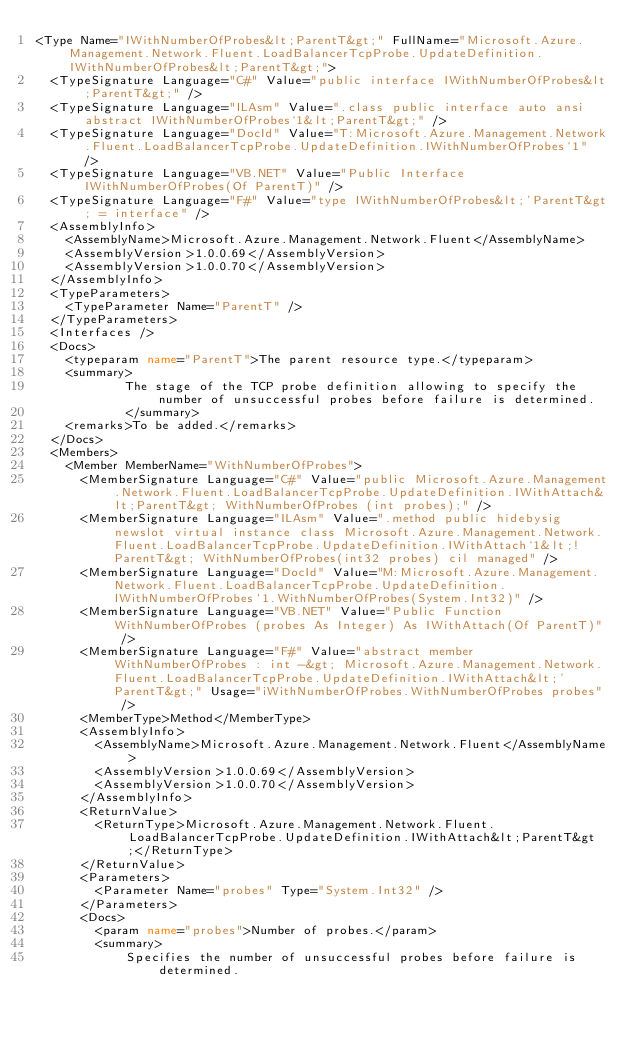Convert code to text. <code><loc_0><loc_0><loc_500><loc_500><_XML_><Type Name="IWithNumberOfProbes&lt;ParentT&gt;" FullName="Microsoft.Azure.Management.Network.Fluent.LoadBalancerTcpProbe.UpdateDefinition.IWithNumberOfProbes&lt;ParentT&gt;">
  <TypeSignature Language="C#" Value="public interface IWithNumberOfProbes&lt;ParentT&gt;" />
  <TypeSignature Language="ILAsm" Value=".class public interface auto ansi abstract IWithNumberOfProbes`1&lt;ParentT&gt;" />
  <TypeSignature Language="DocId" Value="T:Microsoft.Azure.Management.Network.Fluent.LoadBalancerTcpProbe.UpdateDefinition.IWithNumberOfProbes`1" />
  <TypeSignature Language="VB.NET" Value="Public Interface IWithNumberOfProbes(Of ParentT)" />
  <TypeSignature Language="F#" Value="type IWithNumberOfProbes&lt;'ParentT&gt; = interface" />
  <AssemblyInfo>
    <AssemblyName>Microsoft.Azure.Management.Network.Fluent</AssemblyName>
    <AssemblyVersion>1.0.0.69</AssemblyVersion>
    <AssemblyVersion>1.0.0.70</AssemblyVersion>
  </AssemblyInfo>
  <TypeParameters>
    <TypeParameter Name="ParentT" />
  </TypeParameters>
  <Interfaces />
  <Docs>
    <typeparam name="ParentT">The parent resource type.</typeparam>
    <summary>
            The stage of the TCP probe definition allowing to specify the number of unsuccessful probes before failure is determined.
            </summary>
    <remarks>To be added.</remarks>
  </Docs>
  <Members>
    <Member MemberName="WithNumberOfProbes">
      <MemberSignature Language="C#" Value="public Microsoft.Azure.Management.Network.Fluent.LoadBalancerTcpProbe.UpdateDefinition.IWithAttach&lt;ParentT&gt; WithNumberOfProbes (int probes);" />
      <MemberSignature Language="ILAsm" Value=".method public hidebysig newslot virtual instance class Microsoft.Azure.Management.Network.Fluent.LoadBalancerTcpProbe.UpdateDefinition.IWithAttach`1&lt;!ParentT&gt; WithNumberOfProbes(int32 probes) cil managed" />
      <MemberSignature Language="DocId" Value="M:Microsoft.Azure.Management.Network.Fluent.LoadBalancerTcpProbe.UpdateDefinition.IWithNumberOfProbes`1.WithNumberOfProbes(System.Int32)" />
      <MemberSignature Language="VB.NET" Value="Public Function WithNumberOfProbes (probes As Integer) As IWithAttach(Of ParentT)" />
      <MemberSignature Language="F#" Value="abstract member WithNumberOfProbes : int -&gt; Microsoft.Azure.Management.Network.Fluent.LoadBalancerTcpProbe.UpdateDefinition.IWithAttach&lt;'ParentT&gt;" Usage="iWithNumberOfProbes.WithNumberOfProbes probes" />
      <MemberType>Method</MemberType>
      <AssemblyInfo>
        <AssemblyName>Microsoft.Azure.Management.Network.Fluent</AssemblyName>
        <AssemblyVersion>1.0.0.69</AssemblyVersion>
        <AssemblyVersion>1.0.0.70</AssemblyVersion>
      </AssemblyInfo>
      <ReturnValue>
        <ReturnType>Microsoft.Azure.Management.Network.Fluent.LoadBalancerTcpProbe.UpdateDefinition.IWithAttach&lt;ParentT&gt;</ReturnType>
      </ReturnValue>
      <Parameters>
        <Parameter Name="probes" Type="System.Int32" />
      </Parameters>
      <Docs>
        <param name="probes">Number of probes.</param>
        <summary>
            Specifies the number of unsuccessful probes before failure is determined.</code> 